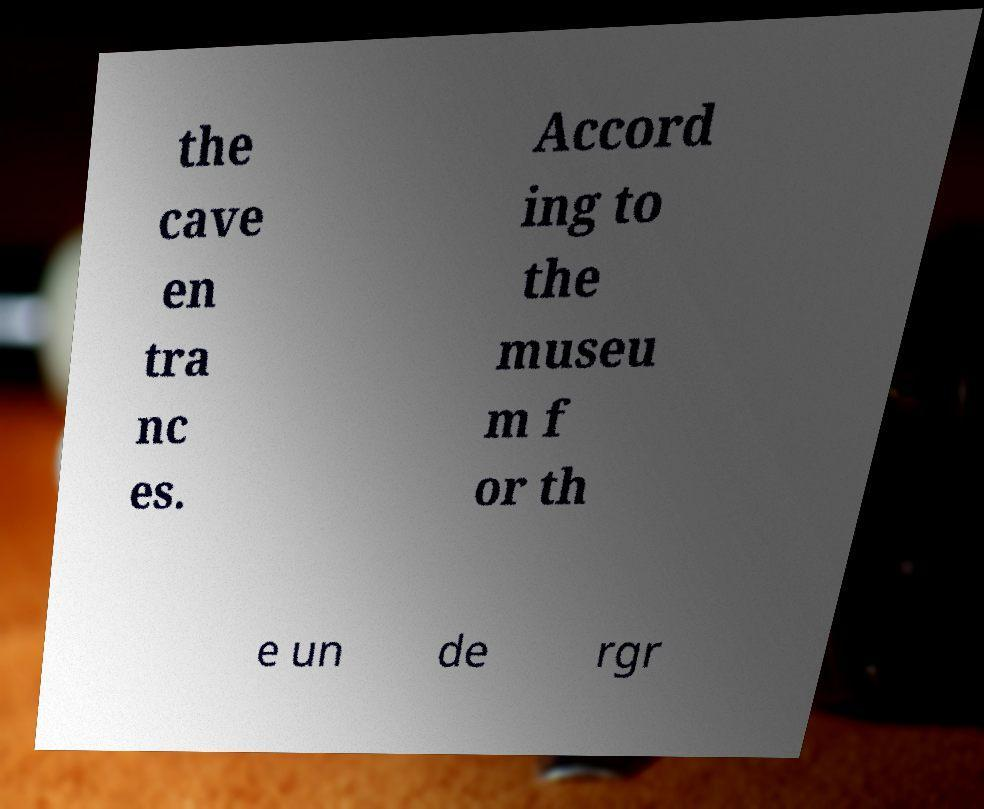Please identify and transcribe the text found in this image. the cave en tra nc es. Accord ing to the museu m f or th e un de rgr 